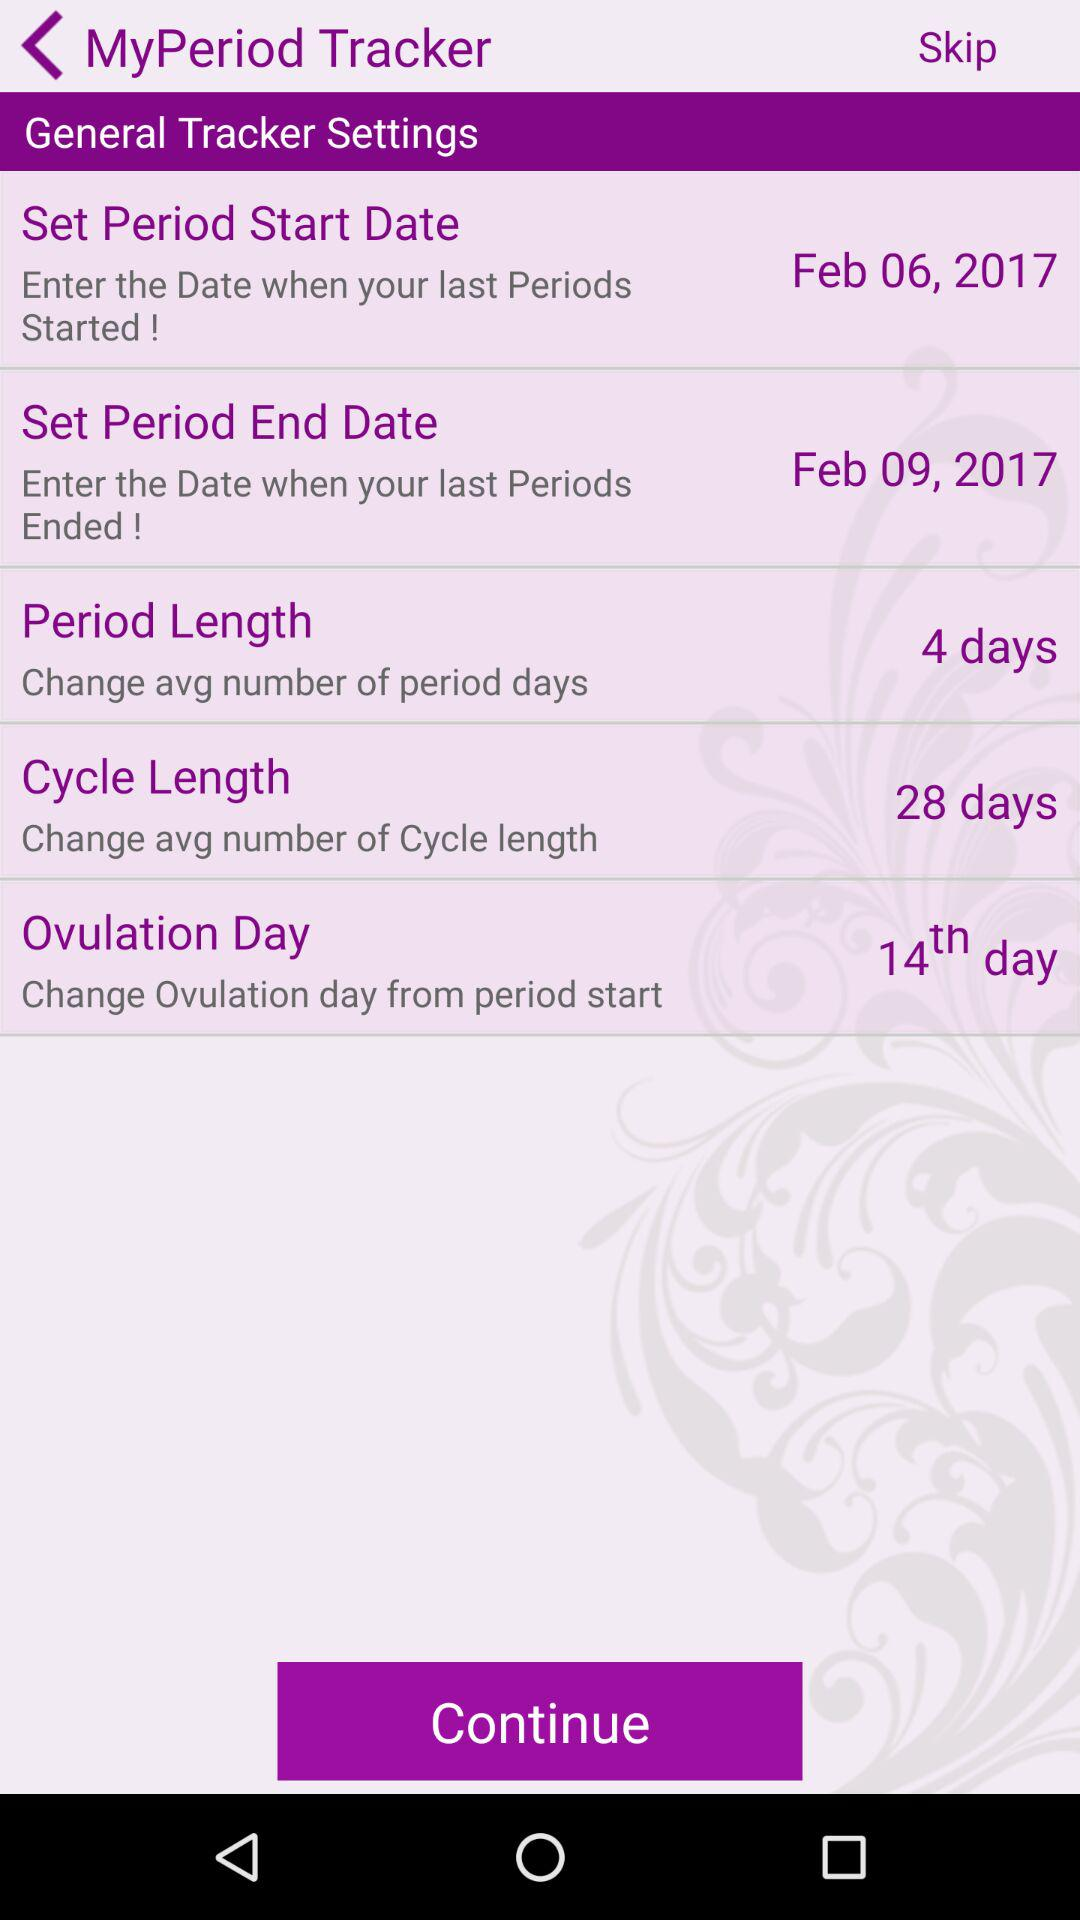What is the period start date? The period start date is February 6, 2017. 